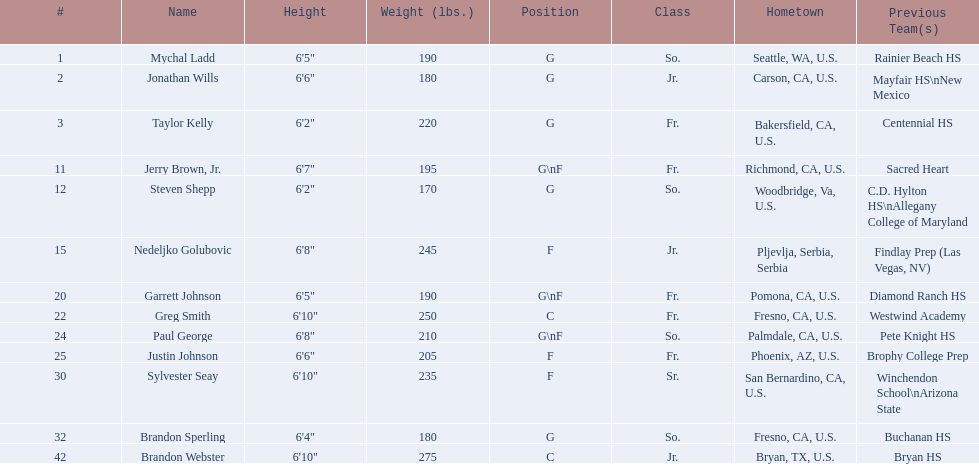Who took part in the 2009-10 fresno state bulldogs men's basketball lineup? Mychal Ladd, Jonathan Wills, Taylor Kelly, Jerry Brown, Jr., Steven Shepp, Nedeljko Golubovic, Garrett Johnson, Greg Smith, Paul George, Justin Johnson, Sylvester Seay, Brandon Sperling, Brandon Webster. What was the role of each participant? G, G, G, G\nF, G, F, G\nF, C, G\nF, F, F, G, C. And how tall were they? 6'5", 6'6", 6'2", 6'7", 6'2", 6'8", 6'5", 6'10", 6'8", 6'6", 6'10", 6'4", 6'10". Of these players, who was the least tall forward? Justin Johnson. 